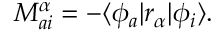Convert formula to latex. <formula><loc_0><loc_0><loc_500><loc_500>\begin{array} { r } { M _ { a i } ^ { \alpha } = - \langle \phi _ { a } | r _ { \alpha } | \phi _ { i } \rangle . } \end{array}</formula> 